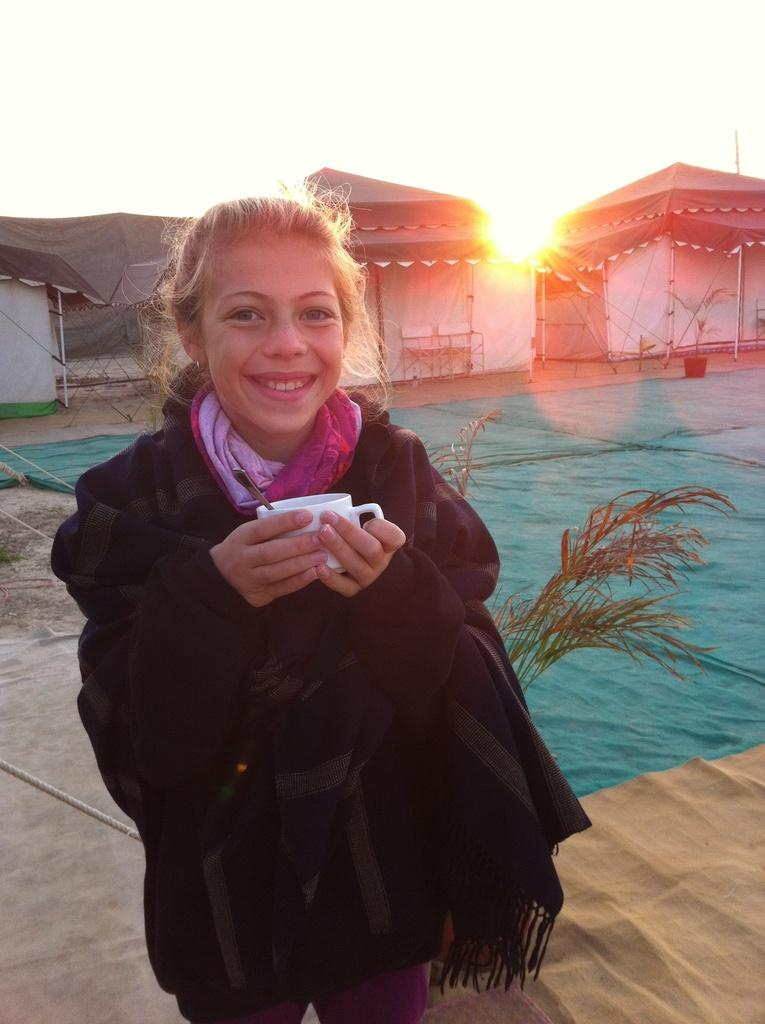What is the woman in the image doing? The woman is standing on the floor and holding a cup in her hands. What can be seen in the background of the image? There are tents visible in the background of the image. How many tramps are jumping in the image? There are no tramps or jumping activities depicted in the image. What type of planes can be seen flying overhead in the image? There are no planes visible in the image. 